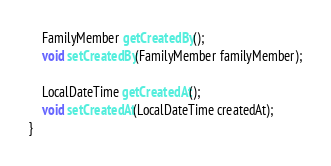Convert code to text. <code><loc_0><loc_0><loc_500><loc_500><_Java_>    FamilyMember getCreatedBy();
    void setCreatedBy(FamilyMember familyMember);

    LocalDateTime getCreatedAt();
    void setCreatedAt(LocalDateTime createdAt);
}
</code> 